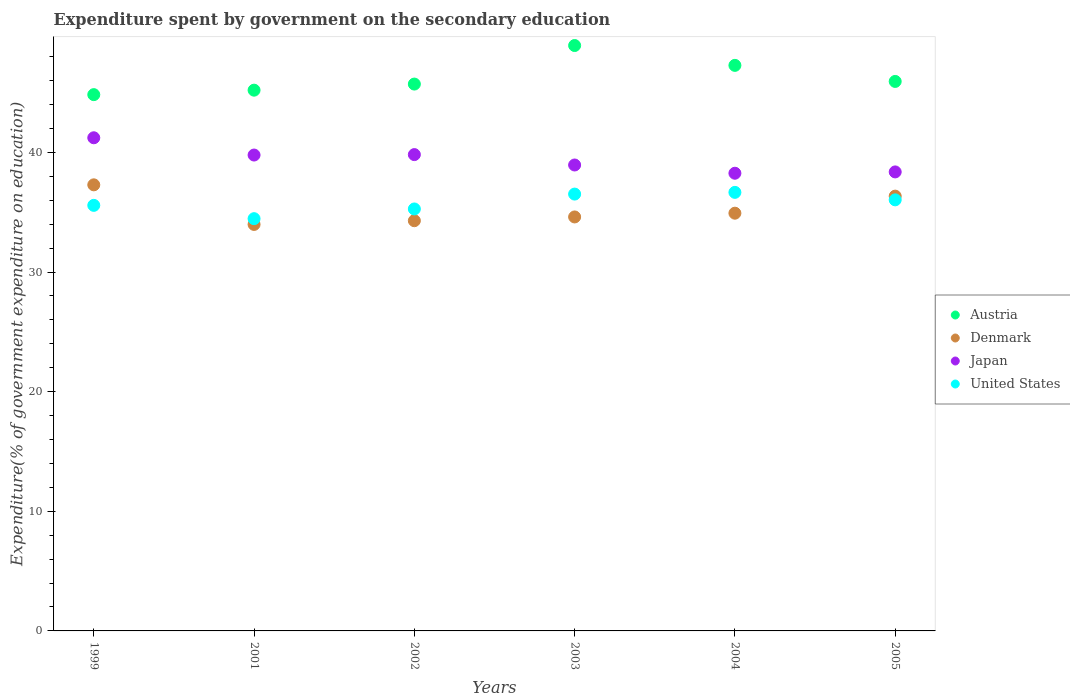How many different coloured dotlines are there?
Your answer should be compact. 4. What is the expenditure spent by government on the secondary education in Japan in 2002?
Provide a succinct answer. 39.82. Across all years, what is the maximum expenditure spent by government on the secondary education in Austria?
Make the answer very short. 48.94. Across all years, what is the minimum expenditure spent by government on the secondary education in Japan?
Your answer should be compact. 38.26. In which year was the expenditure spent by government on the secondary education in Austria maximum?
Keep it short and to the point. 2003. In which year was the expenditure spent by government on the secondary education in Denmark minimum?
Give a very brief answer. 2001. What is the total expenditure spent by government on the secondary education in United States in the graph?
Offer a terse response. 214.54. What is the difference between the expenditure spent by government on the secondary education in Japan in 1999 and that in 2002?
Provide a short and direct response. 1.41. What is the difference between the expenditure spent by government on the secondary education in United States in 2002 and the expenditure spent by government on the secondary education in Denmark in 2005?
Provide a short and direct response. -1.07. What is the average expenditure spent by government on the secondary education in Japan per year?
Offer a very short reply. 39.4. In the year 2004, what is the difference between the expenditure spent by government on the secondary education in Denmark and expenditure spent by government on the secondary education in United States?
Your answer should be very brief. -1.74. What is the ratio of the expenditure spent by government on the secondary education in Japan in 1999 to that in 2001?
Your response must be concise. 1.04. Is the expenditure spent by government on the secondary education in Denmark in 1999 less than that in 2004?
Make the answer very short. No. Is the difference between the expenditure spent by government on the secondary education in Denmark in 1999 and 2005 greater than the difference between the expenditure spent by government on the secondary education in United States in 1999 and 2005?
Provide a succinct answer. Yes. What is the difference between the highest and the second highest expenditure spent by government on the secondary education in United States?
Keep it short and to the point. 0.14. What is the difference between the highest and the lowest expenditure spent by government on the secondary education in United States?
Your response must be concise. 2.2. Is it the case that in every year, the sum of the expenditure spent by government on the secondary education in Denmark and expenditure spent by government on the secondary education in Japan  is greater than the sum of expenditure spent by government on the secondary education in Austria and expenditure spent by government on the secondary education in United States?
Offer a terse response. Yes. Is it the case that in every year, the sum of the expenditure spent by government on the secondary education in Austria and expenditure spent by government on the secondary education in Japan  is greater than the expenditure spent by government on the secondary education in United States?
Your response must be concise. Yes. Is the expenditure spent by government on the secondary education in United States strictly greater than the expenditure spent by government on the secondary education in Austria over the years?
Offer a very short reply. No. Is the expenditure spent by government on the secondary education in Austria strictly less than the expenditure spent by government on the secondary education in Japan over the years?
Your response must be concise. No. What is the difference between two consecutive major ticks on the Y-axis?
Offer a very short reply. 10. Does the graph contain any zero values?
Your answer should be very brief. No. How are the legend labels stacked?
Offer a terse response. Vertical. What is the title of the graph?
Offer a terse response. Expenditure spent by government on the secondary education. Does "St. Lucia" appear as one of the legend labels in the graph?
Your answer should be compact. No. What is the label or title of the Y-axis?
Your answer should be compact. Expenditure(% of government expenditure on education). What is the Expenditure(% of government expenditure on education) of Austria in 1999?
Make the answer very short. 44.83. What is the Expenditure(% of government expenditure on education) of Denmark in 1999?
Your answer should be very brief. 37.29. What is the Expenditure(% of government expenditure on education) of Japan in 1999?
Offer a very short reply. 41.23. What is the Expenditure(% of government expenditure on education) of United States in 1999?
Your answer should be very brief. 35.58. What is the Expenditure(% of government expenditure on education) of Austria in 2001?
Offer a terse response. 45.21. What is the Expenditure(% of government expenditure on education) in Denmark in 2001?
Offer a terse response. 33.98. What is the Expenditure(% of government expenditure on education) in Japan in 2001?
Offer a terse response. 39.78. What is the Expenditure(% of government expenditure on education) in United States in 2001?
Your answer should be very brief. 34.46. What is the Expenditure(% of government expenditure on education) in Austria in 2002?
Make the answer very short. 45.72. What is the Expenditure(% of government expenditure on education) of Denmark in 2002?
Provide a succinct answer. 34.29. What is the Expenditure(% of government expenditure on education) in Japan in 2002?
Your answer should be compact. 39.82. What is the Expenditure(% of government expenditure on education) of United States in 2002?
Your answer should be very brief. 35.28. What is the Expenditure(% of government expenditure on education) in Austria in 2003?
Your answer should be compact. 48.94. What is the Expenditure(% of government expenditure on education) of Denmark in 2003?
Your response must be concise. 34.61. What is the Expenditure(% of government expenditure on education) of Japan in 2003?
Make the answer very short. 38.95. What is the Expenditure(% of government expenditure on education) in United States in 2003?
Offer a terse response. 36.52. What is the Expenditure(% of government expenditure on education) in Austria in 2004?
Ensure brevity in your answer.  47.28. What is the Expenditure(% of government expenditure on education) in Denmark in 2004?
Ensure brevity in your answer.  34.92. What is the Expenditure(% of government expenditure on education) in Japan in 2004?
Give a very brief answer. 38.26. What is the Expenditure(% of government expenditure on education) of United States in 2004?
Your response must be concise. 36.66. What is the Expenditure(% of government expenditure on education) in Austria in 2005?
Make the answer very short. 45.94. What is the Expenditure(% of government expenditure on education) of Denmark in 2005?
Your answer should be compact. 36.35. What is the Expenditure(% of government expenditure on education) of Japan in 2005?
Ensure brevity in your answer.  38.37. What is the Expenditure(% of government expenditure on education) in United States in 2005?
Offer a terse response. 36.04. Across all years, what is the maximum Expenditure(% of government expenditure on education) of Austria?
Provide a short and direct response. 48.94. Across all years, what is the maximum Expenditure(% of government expenditure on education) of Denmark?
Give a very brief answer. 37.29. Across all years, what is the maximum Expenditure(% of government expenditure on education) of Japan?
Your response must be concise. 41.23. Across all years, what is the maximum Expenditure(% of government expenditure on education) of United States?
Give a very brief answer. 36.66. Across all years, what is the minimum Expenditure(% of government expenditure on education) of Austria?
Give a very brief answer. 44.83. Across all years, what is the minimum Expenditure(% of government expenditure on education) of Denmark?
Your response must be concise. 33.98. Across all years, what is the minimum Expenditure(% of government expenditure on education) in Japan?
Provide a succinct answer. 38.26. Across all years, what is the minimum Expenditure(% of government expenditure on education) in United States?
Your answer should be compact. 34.46. What is the total Expenditure(% of government expenditure on education) of Austria in the graph?
Make the answer very short. 277.91. What is the total Expenditure(% of government expenditure on education) of Denmark in the graph?
Provide a succinct answer. 211.45. What is the total Expenditure(% of government expenditure on education) of Japan in the graph?
Make the answer very short. 236.42. What is the total Expenditure(% of government expenditure on education) of United States in the graph?
Give a very brief answer. 214.54. What is the difference between the Expenditure(% of government expenditure on education) in Austria in 1999 and that in 2001?
Provide a succinct answer. -0.37. What is the difference between the Expenditure(% of government expenditure on education) in Denmark in 1999 and that in 2001?
Ensure brevity in your answer.  3.31. What is the difference between the Expenditure(% of government expenditure on education) of Japan in 1999 and that in 2001?
Keep it short and to the point. 1.44. What is the difference between the Expenditure(% of government expenditure on education) in United States in 1999 and that in 2001?
Provide a short and direct response. 1.11. What is the difference between the Expenditure(% of government expenditure on education) in Austria in 1999 and that in 2002?
Offer a very short reply. -0.88. What is the difference between the Expenditure(% of government expenditure on education) of Denmark in 1999 and that in 2002?
Give a very brief answer. 3. What is the difference between the Expenditure(% of government expenditure on education) of Japan in 1999 and that in 2002?
Provide a short and direct response. 1.41. What is the difference between the Expenditure(% of government expenditure on education) in United States in 1999 and that in 2002?
Your answer should be compact. 0.3. What is the difference between the Expenditure(% of government expenditure on education) in Austria in 1999 and that in 2003?
Your answer should be compact. -4.11. What is the difference between the Expenditure(% of government expenditure on education) of Denmark in 1999 and that in 2003?
Provide a short and direct response. 2.68. What is the difference between the Expenditure(% of government expenditure on education) in Japan in 1999 and that in 2003?
Your response must be concise. 2.27. What is the difference between the Expenditure(% of government expenditure on education) of United States in 1999 and that in 2003?
Make the answer very short. -0.94. What is the difference between the Expenditure(% of government expenditure on education) in Austria in 1999 and that in 2004?
Your answer should be very brief. -2.45. What is the difference between the Expenditure(% of government expenditure on education) in Denmark in 1999 and that in 2004?
Make the answer very short. 2.37. What is the difference between the Expenditure(% of government expenditure on education) of Japan in 1999 and that in 2004?
Your answer should be very brief. 2.96. What is the difference between the Expenditure(% of government expenditure on education) in United States in 1999 and that in 2004?
Provide a succinct answer. -1.09. What is the difference between the Expenditure(% of government expenditure on education) in Austria in 1999 and that in 2005?
Your response must be concise. -1.1. What is the difference between the Expenditure(% of government expenditure on education) in Denmark in 1999 and that in 2005?
Keep it short and to the point. 0.94. What is the difference between the Expenditure(% of government expenditure on education) in Japan in 1999 and that in 2005?
Keep it short and to the point. 2.85. What is the difference between the Expenditure(% of government expenditure on education) in United States in 1999 and that in 2005?
Give a very brief answer. -0.46. What is the difference between the Expenditure(% of government expenditure on education) of Austria in 2001 and that in 2002?
Your response must be concise. -0.51. What is the difference between the Expenditure(% of government expenditure on education) of Denmark in 2001 and that in 2002?
Keep it short and to the point. -0.31. What is the difference between the Expenditure(% of government expenditure on education) in Japan in 2001 and that in 2002?
Give a very brief answer. -0.04. What is the difference between the Expenditure(% of government expenditure on education) of United States in 2001 and that in 2002?
Ensure brevity in your answer.  -0.81. What is the difference between the Expenditure(% of government expenditure on education) in Austria in 2001 and that in 2003?
Give a very brief answer. -3.73. What is the difference between the Expenditure(% of government expenditure on education) of Denmark in 2001 and that in 2003?
Keep it short and to the point. -0.63. What is the difference between the Expenditure(% of government expenditure on education) of Japan in 2001 and that in 2003?
Give a very brief answer. 0.83. What is the difference between the Expenditure(% of government expenditure on education) of United States in 2001 and that in 2003?
Provide a succinct answer. -2.06. What is the difference between the Expenditure(% of government expenditure on education) in Austria in 2001 and that in 2004?
Offer a terse response. -2.07. What is the difference between the Expenditure(% of government expenditure on education) in Denmark in 2001 and that in 2004?
Your answer should be very brief. -0.94. What is the difference between the Expenditure(% of government expenditure on education) in Japan in 2001 and that in 2004?
Provide a succinct answer. 1.52. What is the difference between the Expenditure(% of government expenditure on education) of United States in 2001 and that in 2004?
Offer a terse response. -2.2. What is the difference between the Expenditure(% of government expenditure on education) of Austria in 2001 and that in 2005?
Ensure brevity in your answer.  -0.73. What is the difference between the Expenditure(% of government expenditure on education) of Denmark in 2001 and that in 2005?
Your answer should be compact. -2.37. What is the difference between the Expenditure(% of government expenditure on education) in Japan in 2001 and that in 2005?
Your response must be concise. 1.41. What is the difference between the Expenditure(% of government expenditure on education) of United States in 2001 and that in 2005?
Provide a short and direct response. -1.57. What is the difference between the Expenditure(% of government expenditure on education) of Austria in 2002 and that in 2003?
Provide a succinct answer. -3.22. What is the difference between the Expenditure(% of government expenditure on education) in Denmark in 2002 and that in 2003?
Offer a terse response. -0.31. What is the difference between the Expenditure(% of government expenditure on education) in Japan in 2002 and that in 2003?
Your response must be concise. 0.87. What is the difference between the Expenditure(% of government expenditure on education) in United States in 2002 and that in 2003?
Ensure brevity in your answer.  -1.24. What is the difference between the Expenditure(% of government expenditure on education) in Austria in 2002 and that in 2004?
Your answer should be compact. -1.56. What is the difference between the Expenditure(% of government expenditure on education) in Denmark in 2002 and that in 2004?
Ensure brevity in your answer.  -0.63. What is the difference between the Expenditure(% of government expenditure on education) in Japan in 2002 and that in 2004?
Provide a short and direct response. 1.56. What is the difference between the Expenditure(% of government expenditure on education) of United States in 2002 and that in 2004?
Your answer should be compact. -1.39. What is the difference between the Expenditure(% of government expenditure on education) of Austria in 2002 and that in 2005?
Make the answer very short. -0.22. What is the difference between the Expenditure(% of government expenditure on education) in Denmark in 2002 and that in 2005?
Your answer should be compact. -2.05. What is the difference between the Expenditure(% of government expenditure on education) in Japan in 2002 and that in 2005?
Offer a very short reply. 1.45. What is the difference between the Expenditure(% of government expenditure on education) in United States in 2002 and that in 2005?
Your response must be concise. -0.76. What is the difference between the Expenditure(% of government expenditure on education) in Austria in 2003 and that in 2004?
Your response must be concise. 1.66. What is the difference between the Expenditure(% of government expenditure on education) in Denmark in 2003 and that in 2004?
Your response must be concise. -0.31. What is the difference between the Expenditure(% of government expenditure on education) of Japan in 2003 and that in 2004?
Provide a short and direct response. 0.69. What is the difference between the Expenditure(% of government expenditure on education) in United States in 2003 and that in 2004?
Provide a succinct answer. -0.14. What is the difference between the Expenditure(% of government expenditure on education) in Austria in 2003 and that in 2005?
Provide a short and direct response. 3. What is the difference between the Expenditure(% of government expenditure on education) in Denmark in 2003 and that in 2005?
Offer a terse response. -1.74. What is the difference between the Expenditure(% of government expenditure on education) in Japan in 2003 and that in 2005?
Your answer should be very brief. 0.58. What is the difference between the Expenditure(% of government expenditure on education) in United States in 2003 and that in 2005?
Ensure brevity in your answer.  0.48. What is the difference between the Expenditure(% of government expenditure on education) in Austria in 2004 and that in 2005?
Make the answer very short. 1.34. What is the difference between the Expenditure(% of government expenditure on education) of Denmark in 2004 and that in 2005?
Provide a succinct answer. -1.43. What is the difference between the Expenditure(% of government expenditure on education) in Japan in 2004 and that in 2005?
Provide a short and direct response. -0.11. What is the difference between the Expenditure(% of government expenditure on education) of United States in 2004 and that in 2005?
Ensure brevity in your answer.  0.62. What is the difference between the Expenditure(% of government expenditure on education) in Austria in 1999 and the Expenditure(% of government expenditure on education) in Denmark in 2001?
Give a very brief answer. 10.85. What is the difference between the Expenditure(% of government expenditure on education) of Austria in 1999 and the Expenditure(% of government expenditure on education) of Japan in 2001?
Offer a very short reply. 5.05. What is the difference between the Expenditure(% of government expenditure on education) of Austria in 1999 and the Expenditure(% of government expenditure on education) of United States in 2001?
Keep it short and to the point. 10.37. What is the difference between the Expenditure(% of government expenditure on education) in Denmark in 1999 and the Expenditure(% of government expenditure on education) in Japan in 2001?
Give a very brief answer. -2.49. What is the difference between the Expenditure(% of government expenditure on education) of Denmark in 1999 and the Expenditure(% of government expenditure on education) of United States in 2001?
Offer a terse response. 2.83. What is the difference between the Expenditure(% of government expenditure on education) in Japan in 1999 and the Expenditure(% of government expenditure on education) in United States in 2001?
Offer a terse response. 6.76. What is the difference between the Expenditure(% of government expenditure on education) in Austria in 1999 and the Expenditure(% of government expenditure on education) in Denmark in 2002?
Make the answer very short. 10.54. What is the difference between the Expenditure(% of government expenditure on education) of Austria in 1999 and the Expenditure(% of government expenditure on education) of Japan in 2002?
Make the answer very short. 5.01. What is the difference between the Expenditure(% of government expenditure on education) in Austria in 1999 and the Expenditure(% of government expenditure on education) in United States in 2002?
Your response must be concise. 9.56. What is the difference between the Expenditure(% of government expenditure on education) of Denmark in 1999 and the Expenditure(% of government expenditure on education) of Japan in 2002?
Provide a short and direct response. -2.53. What is the difference between the Expenditure(% of government expenditure on education) in Denmark in 1999 and the Expenditure(% of government expenditure on education) in United States in 2002?
Ensure brevity in your answer.  2.02. What is the difference between the Expenditure(% of government expenditure on education) of Japan in 1999 and the Expenditure(% of government expenditure on education) of United States in 2002?
Your response must be concise. 5.95. What is the difference between the Expenditure(% of government expenditure on education) of Austria in 1999 and the Expenditure(% of government expenditure on education) of Denmark in 2003?
Ensure brevity in your answer.  10.22. What is the difference between the Expenditure(% of government expenditure on education) of Austria in 1999 and the Expenditure(% of government expenditure on education) of Japan in 2003?
Your response must be concise. 5.88. What is the difference between the Expenditure(% of government expenditure on education) of Austria in 1999 and the Expenditure(% of government expenditure on education) of United States in 2003?
Ensure brevity in your answer.  8.31. What is the difference between the Expenditure(% of government expenditure on education) of Denmark in 1999 and the Expenditure(% of government expenditure on education) of Japan in 2003?
Offer a very short reply. -1.66. What is the difference between the Expenditure(% of government expenditure on education) of Denmark in 1999 and the Expenditure(% of government expenditure on education) of United States in 2003?
Your answer should be compact. 0.77. What is the difference between the Expenditure(% of government expenditure on education) of Japan in 1999 and the Expenditure(% of government expenditure on education) of United States in 2003?
Give a very brief answer. 4.71. What is the difference between the Expenditure(% of government expenditure on education) of Austria in 1999 and the Expenditure(% of government expenditure on education) of Denmark in 2004?
Your answer should be very brief. 9.91. What is the difference between the Expenditure(% of government expenditure on education) in Austria in 1999 and the Expenditure(% of government expenditure on education) in Japan in 2004?
Offer a very short reply. 6.57. What is the difference between the Expenditure(% of government expenditure on education) of Austria in 1999 and the Expenditure(% of government expenditure on education) of United States in 2004?
Your answer should be compact. 8.17. What is the difference between the Expenditure(% of government expenditure on education) in Denmark in 1999 and the Expenditure(% of government expenditure on education) in Japan in 2004?
Keep it short and to the point. -0.97. What is the difference between the Expenditure(% of government expenditure on education) in Denmark in 1999 and the Expenditure(% of government expenditure on education) in United States in 2004?
Provide a succinct answer. 0.63. What is the difference between the Expenditure(% of government expenditure on education) in Japan in 1999 and the Expenditure(% of government expenditure on education) in United States in 2004?
Provide a succinct answer. 4.56. What is the difference between the Expenditure(% of government expenditure on education) in Austria in 1999 and the Expenditure(% of government expenditure on education) in Denmark in 2005?
Ensure brevity in your answer.  8.48. What is the difference between the Expenditure(% of government expenditure on education) in Austria in 1999 and the Expenditure(% of government expenditure on education) in Japan in 2005?
Ensure brevity in your answer.  6.46. What is the difference between the Expenditure(% of government expenditure on education) in Austria in 1999 and the Expenditure(% of government expenditure on education) in United States in 2005?
Your answer should be compact. 8.79. What is the difference between the Expenditure(% of government expenditure on education) in Denmark in 1999 and the Expenditure(% of government expenditure on education) in Japan in 2005?
Provide a succinct answer. -1.08. What is the difference between the Expenditure(% of government expenditure on education) in Denmark in 1999 and the Expenditure(% of government expenditure on education) in United States in 2005?
Provide a short and direct response. 1.25. What is the difference between the Expenditure(% of government expenditure on education) in Japan in 1999 and the Expenditure(% of government expenditure on education) in United States in 2005?
Keep it short and to the point. 5.19. What is the difference between the Expenditure(% of government expenditure on education) of Austria in 2001 and the Expenditure(% of government expenditure on education) of Denmark in 2002?
Your response must be concise. 10.91. What is the difference between the Expenditure(% of government expenditure on education) in Austria in 2001 and the Expenditure(% of government expenditure on education) in Japan in 2002?
Provide a succinct answer. 5.39. What is the difference between the Expenditure(% of government expenditure on education) of Austria in 2001 and the Expenditure(% of government expenditure on education) of United States in 2002?
Provide a short and direct response. 9.93. What is the difference between the Expenditure(% of government expenditure on education) of Denmark in 2001 and the Expenditure(% of government expenditure on education) of Japan in 2002?
Make the answer very short. -5.84. What is the difference between the Expenditure(% of government expenditure on education) of Denmark in 2001 and the Expenditure(% of government expenditure on education) of United States in 2002?
Offer a very short reply. -1.29. What is the difference between the Expenditure(% of government expenditure on education) in Japan in 2001 and the Expenditure(% of government expenditure on education) in United States in 2002?
Your answer should be very brief. 4.51. What is the difference between the Expenditure(% of government expenditure on education) of Austria in 2001 and the Expenditure(% of government expenditure on education) of Denmark in 2003?
Offer a very short reply. 10.6. What is the difference between the Expenditure(% of government expenditure on education) of Austria in 2001 and the Expenditure(% of government expenditure on education) of Japan in 2003?
Your answer should be compact. 6.25. What is the difference between the Expenditure(% of government expenditure on education) of Austria in 2001 and the Expenditure(% of government expenditure on education) of United States in 2003?
Ensure brevity in your answer.  8.69. What is the difference between the Expenditure(% of government expenditure on education) in Denmark in 2001 and the Expenditure(% of government expenditure on education) in Japan in 2003?
Your response must be concise. -4.97. What is the difference between the Expenditure(% of government expenditure on education) of Denmark in 2001 and the Expenditure(% of government expenditure on education) of United States in 2003?
Your response must be concise. -2.54. What is the difference between the Expenditure(% of government expenditure on education) of Japan in 2001 and the Expenditure(% of government expenditure on education) of United States in 2003?
Ensure brevity in your answer.  3.26. What is the difference between the Expenditure(% of government expenditure on education) in Austria in 2001 and the Expenditure(% of government expenditure on education) in Denmark in 2004?
Provide a succinct answer. 10.28. What is the difference between the Expenditure(% of government expenditure on education) of Austria in 2001 and the Expenditure(% of government expenditure on education) of Japan in 2004?
Offer a terse response. 6.94. What is the difference between the Expenditure(% of government expenditure on education) of Austria in 2001 and the Expenditure(% of government expenditure on education) of United States in 2004?
Offer a terse response. 8.54. What is the difference between the Expenditure(% of government expenditure on education) in Denmark in 2001 and the Expenditure(% of government expenditure on education) in Japan in 2004?
Keep it short and to the point. -4.28. What is the difference between the Expenditure(% of government expenditure on education) in Denmark in 2001 and the Expenditure(% of government expenditure on education) in United States in 2004?
Keep it short and to the point. -2.68. What is the difference between the Expenditure(% of government expenditure on education) in Japan in 2001 and the Expenditure(% of government expenditure on education) in United States in 2004?
Keep it short and to the point. 3.12. What is the difference between the Expenditure(% of government expenditure on education) of Austria in 2001 and the Expenditure(% of government expenditure on education) of Denmark in 2005?
Provide a succinct answer. 8.86. What is the difference between the Expenditure(% of government expenditure on education) in Austria in 2001 and the Expenditure(% of government expenditure on education) in Japan in 2005?
Offer a very short reply. 6.83. What is the difference between the Expenditure(% of government expenditure on education) of Austria in 2001 and the Expenditure(% of government expenditure on education) of United States in 2005?
Offer a terse response. 9.17. What is the difference between the Expenditure(% of government expenditure on education) in Denmark in 2001 and the Expenditure(% of government expenditure on education) in Japan in 2005?
Provide a short and direct response. -4.39. What is the difference between the Expenditure(% of government expenditure on education) in Denmark in 2001 and the Expenditure(% of government expenditure on education) in United States in 2005?
Keep it short and to the point. -2.06. What is the difference between the Expenditure(% of government expenditure on education) of Japan in 2001 and the Expenditure(% of government expenditure on education) of United States in 2005?
Give a very brief answer. 3.75. What is the difference between the Expenditure(% of government expenditure on education) in Austria in 2002 and the Expenditure(% of government expenditure on education) in Denmark in 2003?
Offer a terse response. 11.11. What is the difference between the Expenditure(% of government expenditure on education) in Austria in 2002 and the Expenditure(% of government expenditure on education) in Japan in 2003?
Provide a short and direct response. 6.76. What is the difference between the Expenditure(% of government expenditure on education) of Austria in 2002 and the Expenditure(% of government expenditure on education) of United States in 2003?
Give a very brief answer. 9.2. What is the difference between the Expenditure(% of government expenditure on education) in Denmark in 2002 and the Expenditure(% of government expenditure on education) in Japan in 2003?
Your answer should be compact. -4.66. What is the difference between the Expenditure(% of government expenditure on education) in Denmark in 2002 and the Expenditure(% of government expenditure on education) in United States in 2003?
Provide a succinct answer. -2.23. What is the difference between the Expenditure(% of government expenditure on education) in Japan in 2002 and the Expenditure(% of government expenditure on education) in United States in 2003?
Your answer should be very brief. 3.3. What is the difference between the Expenditure(% of government expenditure on education) in Austria in 2002 and the Expenditure(% of government expenditure on education) in Denmark in 2004?
Offer a very short reply. 10.79. What is the difference between the Expenditure(% of government expenditure on education) in Austria in 2002 and the Expenditure(% of government expenditure on education) in Japan in 2004?
Make the answer very short. 7.45. What is the difference between the Expenditure(% of government expenditure on education) in Austria in 2002 and the Expenditure(% of government expenditure on education) in United States in 2004?
Offer a very short reply. 9.05. What is the difference between the Expenditure(% of government expenditure on education) in Denmark in 2002 and the Expenditure(% of government expenditure on education) in Japan in 2004?
Offer a terse response. -3.97. What is the difference between the Expenditure(% of government expenditure on education) of Denmark in 2002 and the Expenditure(% of government expenditure on education) of United States in 2004?
Offer a very short reply. -2.37. What is the difference between the Expenditure(% of government expenditure on education) of Japan in 2002 and the Expenditure(% of government expenditure on education) of United States in 2004?
Your answer should be compact. 3.16. What is the difference between the Expenditure(% of government expenditure on education) of Austria in 2002 and the Expenditure(% of government expenditure on education) of Denmark in 2005?
Your response must be concise. 9.37. What is the difference between the Expenditure(% of government expenditure on education) in Austria in 2002 and the Expenditure(% of government expenditure on education) in Japan in 2005?
Keep it short and to the point. 7.34. What is the difference between the Expenditure(% of government expenditure on education) of Austria in 2002 and the Expenditure(% of government expenditure on education) of United States in 2005?
Provide a short and direct response. 9.68. What is the difference between the Expenditure(% of government expenditure on education) of Denmark in 2002 and the Expenditure(% of government expenditure on education) of Japan in 2005?
Offer a very short reply. -4.08. What is the difference between the Expenditure(% of government expenditure on education) in Denmark in 2002 and the Expenditure(% of government expenditure on education) in United States in 2005?
Provide a short and direct response. -1.74. What is the difference between the Expenditure(% of government expenditure on education) in Japan in 2002 and the Expenditure(% of government expenditure on education) in United States in 2005?
Keep it short and to the point. 3.78. What is the difference between the Expenditure(% of government expenditure on education) in Austria in 2003 and the Expenditure(% of government expenditure on education) in Denmark in 2004?
Provide a succinct answer. 14.02. What is the difference between the Expenditure(% of government expenditure on education) in Austria in 2003 and the Expenditure(% of government expenditure on education) in Japan in 2004?
Make the answer very short. 10.68. What is the difference between the Expenditure(% of government expenditure on education) of Austria in 2003 and the Expenditure(% of government expenditure on education) of United States in 2004?
Make the answer very short. 12.28. What is the difference between the Expenditure(% of government expenditure on education) in Denmark in 2003 and the Expenditure(% of government expenditure on education) in Japan in 2004?
Provide a short and direct response. -3.65. What is the difference between the Expenditure(% of government expenditure on education) of Denmark in 2003 and the Expenditure(% of government expenditure on education) of United States in 2004?
Your answer should be compact. -2.05. What is the difference between the Expenditure(% of government expenditure on education) in Japan in 2003 and the Expenditure(% of government expenditure on education) in United States in 2004?
Your response must be concise. 2.29. What is the difference between the Expenditure(% of government expenditure on education) of Austria in 2003 and the Expenditure(% of government expenditure on education) of Denmark in 2005?
Your answer should be compact. 12.59. What is the difference between the Expenditure(% of government expenditure on education) of Austria in 2003 and the Expenditure(% of government expenditure on education) of Japan in 2005?
Offer a very short reply. 10.57. What is the difference between the Expenditure(% of government expenditure on education) of Austria in 2003 and the Expenditure(% of government expenditure on education) of United States in 2005?
Your answer should be very brief. 12.9. What is the difference between the Expenditure(% of government expenditure on education) of Denmark in 2003 and the Expenditure(% of government expenditure on education) of Japan in 2005?
Give a very brief answer. -3.76. What is the difference between the Expenditure(% of government expenditure on education) in Denmark in 2003 and the Expenditure(% of government expenditure on education) in United States in 2005?
Offer a very short reply. -1.43. What is the difference between the Expenditure(% of government expenditure on education) of Japan in 2003 and the Expenditure(% of government expenditure on education) of United States in 2005?
Make the answer very short. 2.91. What is the difference between the Expenditure(% of government expenditure on education) in Austria in 2004 and the Expenditure(% of government expenditure on education) in Denmark in 2005?
Offer a very short reply. 10.93. What is the difference between the Expenditure(% of government expenditure on education) in Austria in 2004 and the Expenditure(% of government expenditure on education) in Japan in 2005?
Ensure brevity in your answer.  8.91. What is the difference between the Expenditure(% of government expenditure on education) in Austria in 2004 and the Expenditure(% of government expenditure on education) in United States in 2005?
Offer a very short reply. 11.24. What is the difference between the Expenditure(% of government expenditure on education) in Denmark in 2004 and the Expenditure(% of government expenditure on education) in Japan in 2005?
Your response must be concise. -3.45. What is the difference between the Expenditure(% of government expenditure on education) in Denmark in 2004 and the Expenditure(% of government expenditure on education) in United States in 2005?
Keep it short and to the point. -1.12. What is the difference between the Expenditure(% of government expenditure on education) in Japan in 2004 and the Expenditure(% of government expenditure on education) in United States in 2005?
Offer a very short reply. 2.22. What is the average Expenditure(% of government expenditure on education) in Austria per year?
Your response must be concise. 46.32. What is the average Expenditure(% of government expenditure on education) in Denmark per year?
Make the answer very short. 35.24. What is the average Expenditure(% of government expenditure on education) of Japan per year?
Keep it short and to the point. 39.4. What is the average Expenditure(% of government expenditure on education) of United States per year?
Provide a succinct answer. 35.76. In the year 1999, what is the difference between the Expenditure(% of government expenditure on education) of Austria and Expenditure(% of government expenditure on education) of Denmark?
Provide a succinct answer. 7.54. In the year 1999, what is the difference between the Expenditure(% of government expenditure on education) in Austria and Expenditure(% of government expenditure on education) in Japan?
Give a very brief answer. 3.61. In the year 1999, what is the difference between the Expenditure(% of government expenditure on education) in Austria and Expenditure(% of government expenditure on education) in United States?
Make the answer very short. 9.26. In the year 1999, what is the difference between the Expenditure(% of government expenditure on education) of Denmark and Expenditure(% of government expenditure on education) of Japan?
Ensure brevity in your answer.  -3.93. In the year 1999, what is the difference between the Expenditure(% of government expenditure on education) in Denmark and Expenditure(% of government expenditure on education) in United States?
Ensure brevity in your answer.  1.72. In the year 1999, what is the difference between the Expenditure(% of government expenditure on education) in Japan and Expenditure(% of government expenditure on education) in United States?
Keep it short and to the point. 5.65. In the year 2001, what is the difference between the Expenditure(% of government expenditure on education) in Austria and Expenditure(% of government expenditure on education) in Denmark?
Offer a terse response. 11.22. In the year 2001, what is the difference between the Expenditure(% of government expenditure on education) of Austria and Expenditure(% of government expenditure on education) of Japan?
Give a very brief answer. 5.42. In the year 2001, what is the difference between the Expenditure(% of government expenditure on education) of Austria and Expenditure(% of government expenditure on education) of United States?
Your response must be concise. 10.74. In the year 2001, what is the difference between the Expenditure(% of government expenditure on education) in Denmark and Expenditure(% of government expenditure on education) in Japan?
Ensure brevity in your answer.  -5.8. In the year 2001, what is the difference between the Expenditure(% of government expenditure on education) in Denmark and Expenditure(% of government expenditure on education) in United States?
Offer a terse response. -0.48. In the year 2001, what is the difference between the Expenditure(% of government expenditure on education) of Japan and Expenditure(% of government expenditure on education) of United States?
Provide a short and direct response. 5.32. In the year 2002, what is the difference between the Expenditure(% of government expenditure on education) of Austria and Expenditure(% of government expenditure on education) of Denmark?
Provide a succinct answer. 11.42. In the year 2002, what is the difference between the Expenditure(% of government expenditure on education) of Austria and Expenditure(% of government expenditure on education) of Japan?
Keep it short and to the point. 5.9. In the year 2002, what is the difference between the Expenditure(% of government expenditure on education) of Austria and Expenditure(% of government expenditure on education) of United States?
Your answer should be compact. 10.44. In the year 2002, what is the difference between the Expenditure(% of government expenditure on education) of Denmark and Expenditure(% of government expenditure on education) of Japan?
Provide a succinct answer. -5.53. In the year 2002, what is the difference between the Expenditure(% of government expenditure on education) of Denmark and Expenditure(% of government expenditure on education) of United States?
Your answer should be very brief. -0.98. In the year 2002, what is the difference between the Expenditure(% of government expenditure on education) in Japan and Expenditure(% of government expenditure on education) in United States?
Offer a very short reply. 4.54. In the year 2003, what is the difference between the Expenditure(% of government expenditure on education) in Austria and Expenditure(% of government expenditure on education) in Denmark?
Keep it short and to the point. 14.33. In the year 2003, what is the difference between the Expenditure(% of government expenditure on education) of Austria and Expenditure(% of government expenditure on education) of Japan?
Provide a short and direct response. 9.99. In the year 2003, what is the difference between the Expenditure(% of government expenditure on education) of Austria and Expenditure(% of government expenditure on education) of United States?
Provide a short and direct response. 12.42. In the year 2003, what is the difference between the Expenditure(% of government expenditure on education) of Denmark and Expenditure(% of government expenditure on education) of Japan?
Offer a very short reply. -4.34. In the year 2003, what is the difference between the Expenditure(% of government expenditure on education) in Denmark and Expenditure(% of government expenditure on education) in United States?
Make the answer very short. -1.91. In the year 2003, what is the difference between the Expenditure(% of government expenditure on education) in Japan and Expenditure(% of government expenditure on education) in United States?
Offer a terse response. 2.43. In the year 2004, what is the difference between the Expenditure(% of government expenditure on education) of Austria and Expenditure(% of government expenditure on education) of Denmark?
Your response must be concise. 12.36. In the year 2004, what is the difference between the Expenditure(% of government expenditure on education) in Austria and Expenditure(% of government expenditure on education) in Japan?
Ensure brevity in your answer.  9.02. In the year 2004, what is the difference between the Expenditure(% of government expenditure on education) of Austria and Expenditure(% of government expenditure on education) of United States?
Offer a terse response. 10.62. In the year 2004, what is the difference between the Expenditure(% of government expenditure on education) of Denmark and Expenditure(% of government expenditure on education) of Japan?
Make the answer very short. -3.34. In the year 2004, what is the difference between the Expenditure(% of government expenditure on education) in Denmark and Expenditure(% of government expenditure on education) in United States?
Offer a terse response. -1.74. In the year 2005, what is the difference between the Expenditure(% of government expenditure on education) in Austria and Expenditure(% of government expenditure on education) in Denmark?
Your answer should be very brief. 9.59. In the year 2005, what is the difference between the Expenditure(% of government expenditure on education) in Austria and Expenditure(% of government expenditure on education) in Japan?
Offer a very short reply. 7.57. In the year 2005, what is the difference between the Expenditure(% of government expenditure on education) of Austria and Expenditure(% of government expenditure on education) of United States?
Provide a short and direct response. 9.9. In the year 2005, what is the difference between the Expenditure(% of government expenditure on education) in Denmark and Expenditure(% of government expenditure on education) in Japan?
Your answer should be very brief. -2.02. In the year 2005, what is the difference between the Expenditure(% of government expenditure on education) in Denmark and Expenditure(% of government expenditure on education) in United States?
Offer a very short reply. 0.31. In the year 2005, what is the difference between the Expenditure(% of government expenditure on education) of Japan and Expenditure(% of government expenditure on education) of United States?
Your answer should be very brief. 2.33. What is the ratio of the Expenditure(% of government expenditure on education) in Austria in 1999 to that in 2001?
Provide a succinct answer. 0.99. What is the ratio of the Expenditure(% of government expenditure on education) in Denmark in 1999 to that in 2001?
Your response must be concise. 1.1. What is the ratio of the Expenditure(% of government expenditure on education) in Japan in 1999 to that in 2001?
Offer a very short reply. 1.04. What is the ratio of the Expenditure(% of government expenditure on education) of United States in 1999 to that in 2001?
Your answer should be very brief. 1.03. What is the ratio of the Expenditure(% of government expenditure on education) in Austria in 1999 to that in 2002?
Give a very brief answer. 0.98. What is the ratio of the Expenditure(% of government expenditure on education) of Denmark in 1999 to that in 2002?
Make the answer very short. 1.09. What is the ratio of the Expenditure(% of government expenditure on education) in Japan in 1999 to that in 2002?
Offer a very short reply. 1.04. What is the ratio of the Expenditure(% of government expenditure on education) of United States in 1999 to that in 2002?
Keep it short and to the point. 1.01. What is the ratio of the Expenditure(% of government expenditure on education) of Austria in 1999 to that in 2003?
Your response must be concise. 0.92. What is the ratio of the Expenditure(% of government expenditure on education) in Denmark in 1999 to that in 2003?
Offer a terse response. 1.08. What is the ratio of the Expenditure(% of government expenditure on education) of Japan in 1999 to that in 2003?
Make the answer very short. 1.06. What is the ratio of the Expenditure(% of government expenditure on education) in United States in 1999 to that in 2003?
Offer a very short reply. 0.97. What is the ratio of the Expenditure(% of government expenditure on education) of Austria in 1999 to that in 2004?
Keep it short and to the point. 0.95. What is the ratio of the Expenditure(% of government expenditure on education) in Denmark in 1999 to that in 2004?
Ensure brevity in your answer.  1.07. What is the ratio of the Expenditure(% of government expenditure on education) of Japan in 1999 to that in 2004?
Your answer should be compact. 1.08. What is the ratio of the Expenditure(% of government expenditure on education) in United States in 1999 to that in 2004?
Offer a very short reply. 0.97. What is the ratio of the Expenditure(% of government expenditure on education) in Austria in 1999 to that in 2005?
Your response must be concise. 0.98. What is the ratio of the Expenditure(% of government expenditure on education) of Japan in 1999 to that in 2005?
Provide a succinct answer. 1.07. What is the ratio of the Expenditure(% of government expenditure on education) in United States in 1999 to that in 2005?
Your answer should be very brief. 0.99. What is the ratio of the Expenditure(% of government expenditure on education) in Austria in 2001 to that in 2002?
Your response must be concise. 0.99. What is the ratio of the Expenditure(% of government expenditure on education) of Denmark in 2001 to that in 2002?
Your response must be concise. 0.99. What is the ratio of the Expenditure(% of government expenditure on education) of United States in 2001 to that in 2002?
Keep it short and to the point. 0.98. What is the ratio of the Expenditure(% of government expenditure on education) in Austria in 2001 to that in 2003?
Offer a terse response. 0.92. What is the ratio of the Expenditure(% of government expenditure on education) in Denmark in 2001 to that in 2003?
Offer a very short reply. 0.98. What is the ratio of the Expenditure(% of government expenditure on education) of Japan in 2001 to that in 2003?
Ensure brevity in your answer.  1.02. What is the ratio of the Expenditure(% of government expenditure on education) in United States in 2001 to that in 2003?
Your answer should be very brief. 0.94. What is the ratio of the Expenditure(% of government expenditure on education) of Austria in 2001 to that in 2004?
Keep it short and to the point. 0.96. What is the ratio of the Expenditure(% of government expenditure on education) of Denmark in 2001 to that in 2004?
Offer a very short reply. 0.97. What is the ratio of the Expenditure(% of government expenditure on education) in Japan in 2001 to that in 2004?
Ensure brevity in your answer.  1.04. What is the ratio of the Expenditure(% of government expenditure on education) in Austria in 2001 to that in 2005?
Make the answer very short. 0.98. What is the ratio of the Expenditure(% of government expenditure on education) in Denmark in 2001 to that in 2005?
Ensure brevity in your answer.  0.93. What is the ratio of the Expenditure(% of government expenditure on education) of Japan in 2001 to that in 2005?
Give a very brief answer. 1.04. What is the ratio of the Expenditure(% of government expenditure on education) of United States in 2001 to that in 2005?
Make the answer very short. 0.96. What is the ratio of the Expenditure(% of government expenditure on education) of Austria in 2002 to that in 2003?
Keep it short and to the point. 0.93. What is the ratio of the Expenditure(% of government expenditure on education) in Denmark in 2002 to that in 2003?
Ensure brevity in your answer.  0.99. What is the ratio of the Expenditure(% of government expenditure on education) in Japan in 2002 to that in 2003?
Make the answer very short. 1.02. What is the ratio of the Expenditure(% of government expenditure on education) in United States in 2002 to that in 2003?
Offer a terse response. 0.97. What is the ratio of the Expenditure(% of government expenditure on education) in Austria in 2002 to that in 2004?
Your response must be concise. 0.97. What is the ratio of the Expenditure(% of government expenditure on education) of Japan in 2002 to that in 2004?
Your answer should be compact. 1.04. What is the ratio of the Expenditure(% of government expenditure on education) of United States in 2002 to that in 2004?
Offer a very short reply. 0.96. What is the ratio of the Expenditure(% of government expenditure on education) of Austria in 2002 to that in 2005?
Your answer should be very brief. 1. What is the ratio of the Expenditure(% of government expenditure on education) in Denmark in 2002 to that in 2005?
Offer a very short reply. 0.94. What is the ratio of the Expenditure(% of government expenditure on education) in Japan in 2002 to that in 2005?
Your answer should be compact. 1.04. What is the ratio of the Expenditure(% of government expenditure on education) in United States in 2002 to that in 2005?
Provide a succinct answer. 0.98. What is the ratio of the Expenditure(% of government expenditure on education) in Austria in 2003 to that in 2004?
Provide a succinct answer. 1.04. What is the ratio of the Expenditure(% of government expenditure on education) of Japan in 2003 to that in 2004?
Offer a terse response. 1.02. What is the ratio of the Expenditure(% of government expenditure on education) in United States in 2003 to that in 2004?
Offer a very short reply. 1. What is the ratio of the Expenditure(% of government expenditure on education) in Austria in 2003 to that in 2005?
Provide a short and direct response. 1.07. What is the ratio of the Expenditure(% of government expenditure on education) in Denmark in 2003 to that in 2005?
Your response must be concise. 0.95. What is the ratio of the Expenditure(% of government expenditure on education) of Japan in 2003 to that in 2005?
Ensure brevity in your answer.  1.02. What is the ratio of the Expenditure(% of government expenditure on education) in United States in 2003 to that in 2005?
Provide a short and direct response. 1.01. What is the ratio of the Expenditure(% of government expenditure on education) of Austria in 2004 to that in 2005?
Make the answer very short. 1.03. What is the ratio of the Expenditure(% of government expenditure on education) of Denmark in 2004 to that in 2005?
Your answer should be very brief. 0.96. What is the ratio of the Expenditure(% of government expenditure on education) of United States in 2004 to that in 2005?
Offer a very short reply. 1.02. What is the difference between the highest and the second highest Expenditure(% of government expenditure on education) of Austria?
Ensure brevity in your answer.  1.66. What is the difference between the highest and the second highest Expenditure(% of government expenditure on education) in Denmark?
Your response must be concise. 0.94. What is the difference between the highest and the second highest Expenditure(% of government expenditure on education) of Japan?
Make the answer very short. 1.41. What is the difference between the highest and the second highest Expenditure(% of government expenditure on education) of United States?
Make the answer very short. 0.14. What is the difference between the highest and the lowest Expenditure(% of government expenditure on education) of Austria?
Keep it short and to the point. 4.11. What is the difference between the highest and the lowest Expenditure(% of government expenditure on education) of Denmark?
Provide a succinct answer. 3.31. What is the difference between the highest and the lowest Expenditure(% of government expenditure on education) in Japan?
Provide a short and direct response. 2.96. What is the difference between the highest and the lowest Expenditure(% of government expenditure on education) of United States?
Provide a short and direct response. 2.2. 